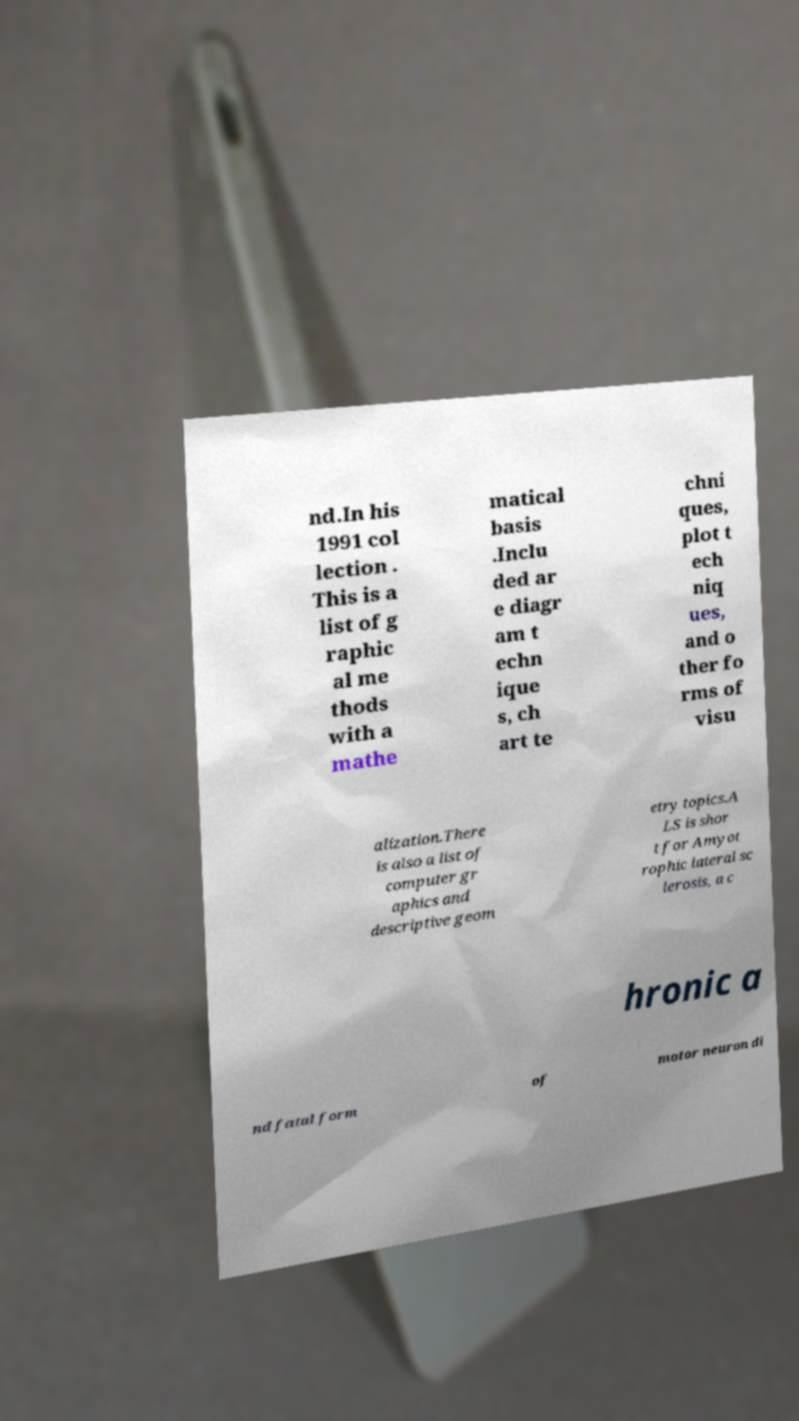Could you assist in decoding the text presented in this image and type it out clearly? nd.In his 1991 col lection . This is a list of g raphic al me thods with a mathe matical basis .Inclu ded ar e diagr am t echn ique s, ch art te chni ques, plot t ech niq ues, and o ther fo rms of visu alization.There is also a list of computer gr aphics and descriptive geom etry topics.A LS is shor t for Amyot rophic lateral sc lerosis, a c hronic a nd fatal form of motor neuron di 